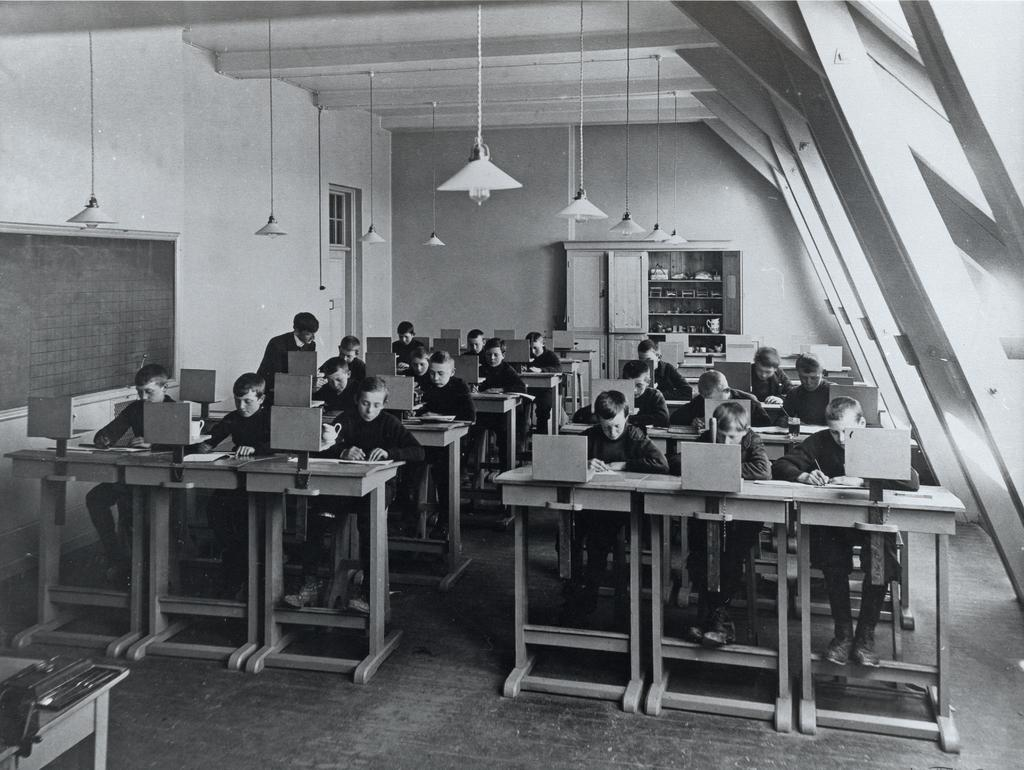How many people are in the image? There is a group of persons in the image. What are the persons doing in the image? The persons are sitting on a table and doing some work. What can be seen in the background of the image? There is a cupboard, lamps, and a wall in the background of the image. What type of whip can be seen in the image? There is no whip present in the image. Can you see a kitten playing with a cover in the image? There is no kitten or cover present in the image. 